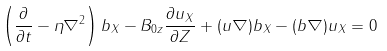<formula> <loc_0><loc_0><loc_500><loc_500>\left ( \frac { \partial } { \partial t } - \eta \nabla ^ { 2 } \right ) b _ { X } - B _ { 0 z } \frac { \partial u _ { X } } { \partial Z } + ( { u } \nabla ) b _ { X } - ( { b } \nabla ) u _ { X } = 0</formula> 